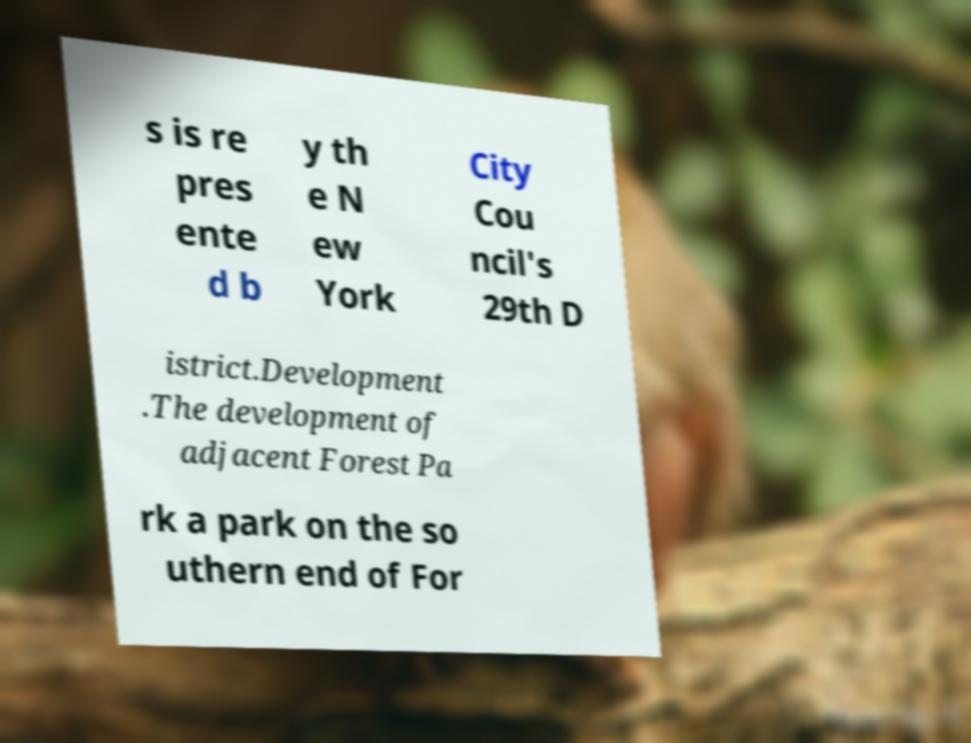For documentation purposes, I need the text within this image transcribed. Could you provide that? s is re pres ente d b y th e N ew York City Cou ncil's 29th D istrict.Development .The development of adjacent Forest Pa rk a park on the so uthern end of For 